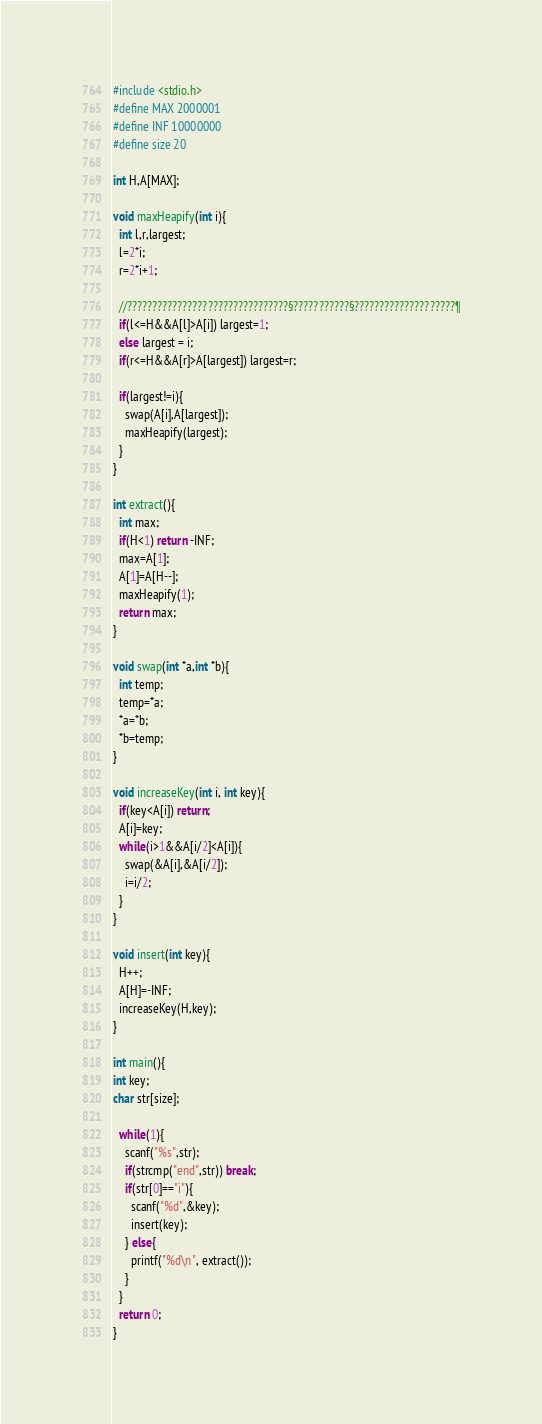<code> <loc_0><loc_0><loc_500><loc_500><_C_>#include <stdio.h>
#define MAX 2000001
#define INF 10000000
#define size 20

int H,A[MAX];

void maxHeapify(int i){
  int l,r,largest;
  l=2*i;
  r=2*i+1;

  //????????????????????????????????§???????????§????????????????????¶
  if(l<=H&&A[l]>A[i]) largest=1;
  else largest = i;
  if(r<=H&&A[r]>A[largest]) largest=r;

  if(largest!=i){
    swap(A[i],A[largest]);
    maxHeapify(largest);
  }
}

int extract(){
  int max;
  if(H<1) return -INF;
  max=A[1];
  A[1]=A[H--];
  maxHeapify(1);
  return max;
}

void swap(int *a,int *b){
  int temp;
  temp=*a;
  *a=*b;
  *b=temp;
}

void increaseKey(int i, int key){
  if(key<A[i]) return;
  A[i]=key;
  while(i>1&&A[i/2]<A[i]){
    swap(&A[i],&A[i/2]);
    i=i/2;
  }
}

void insert(int key){
  H++;
  A[H]=-INF;
  increaseKey(H,key);
}

int main(){
int key;
char str[size];

  while(1){
    scanf("%s",str);
    if(strcmp("end",str)) break;
    if(str[0]=="i"){
      scanf("%d",&key);
      insert(key);
    } else{
      printf("%d\n", extract());
    }
  }
  return 0;
}</code> 